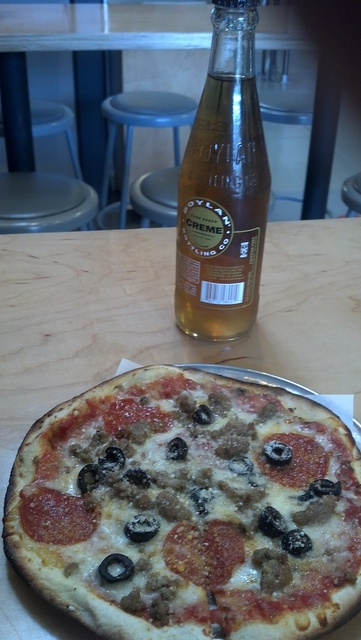Describe the objects in this image and their specific colors. I can see dining table in blue, darkgray, gray, black, and maroon tones, pizza in blue, gray, darkgray, black, and maroon tones, bottle in blue, black, gray, and maroon tones, chair in blue, darkblue, and navy tones, and chair in blue, gray, and navy tones in this image. 